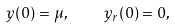<formula> <loc_0><loc_0><loc_500><loc_500>y ( 0 ) = \mu , \quad y _ { r } ( 0 ) = 0 ,</formula> 